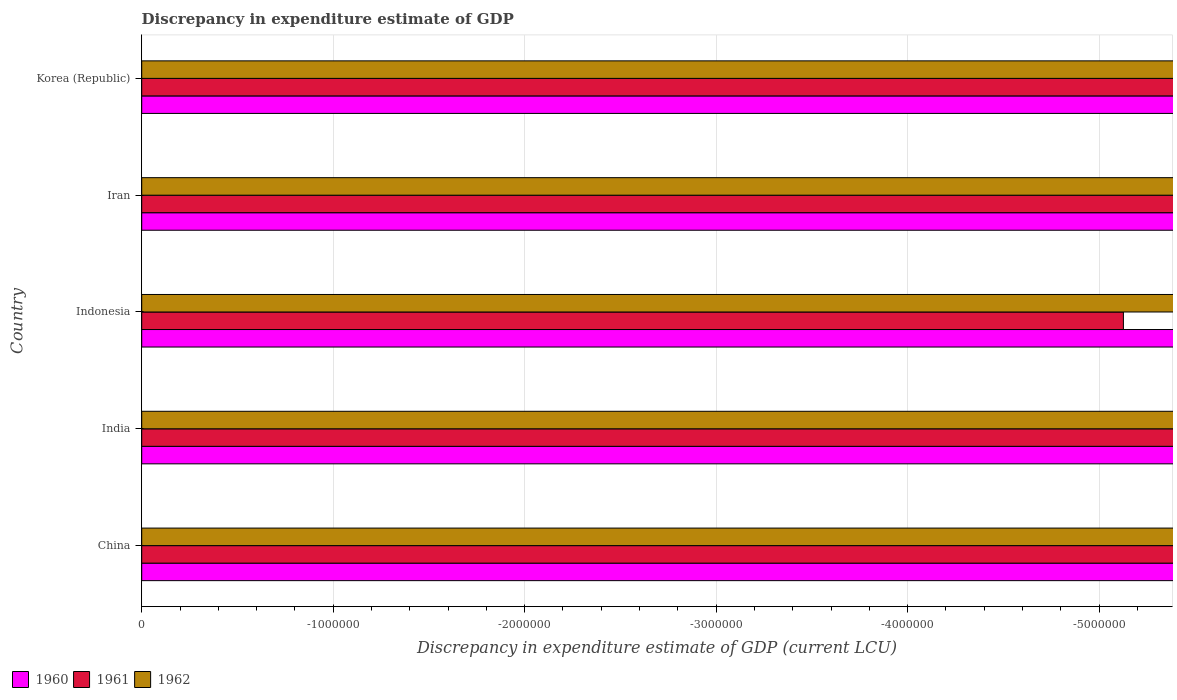How many different coloured bars are there?
Offer a terse response. 0. Are the number of bars per tick equal to the number of legend labels?
Make the answer very short. No. Are the number of bars on each tick of the Y-axis equal?
Your response must be concise. Yes. What is the label of the 1st group of bars from the top?
Provide a succinct answer. Korea (Republic). In how many cases, is the number of bars for a given country not equal to the number of legend labels?
Ensure brevity in your answer.  5. What is the discrepancy in expenditure estimate of GDP in 1960 in Iran?
Keep it short and to the point. 0. What is the average discrepancy in expenditure estimate of GDP in 1962 per country?
Offer a terse response. 0. Is it the case that in every country, the sum of the discrepancy in expenditure estimate of GDP in 1961 and discrepancy in expenditure estimate of GDP in 1960 is greater than the discrepancy in expenditure estimate of GDP in 1962?
Give a very brief answer. No. How many bars are there?
Your response must be concise. 0. What is the difference between two consecutive major ticks on the X-axis?
Your answer should be compact. 1.00e+06. Does the graph contain any zero values?
Keep it short and to the point. Yes. Does the graph contain grids?
Give a very brief answer. Yes. How are the legend labels stacked?
Provide a short and direct response. Horizontal. What is the title of the graph?
Your response must be concise. Discrepancy in expenditure estimate of GDP. Does "1969" appear as one of the legend labels in the graph?
Provide a short and direct response. No. What is the label or title of the X-axis?
Provide a short and direct response. Discrepancy in expenditure estimate of GDP (current LCU). What is the Discrepancy in expenditure estimate of GDP (current LCU) of 1960 in China?
Your response must be concise. 0. What is the Discrepancy in expenditure estimate of GDP (current LCU) of 1962 in India?
Offer a terse response. 0. What is the Discrepancy in expenditure estimate of GDP (current LCU) in 1961 in Indonesia?
Keep it short and to the point. 0. What is the Discrepancy in expenditure estimate of GDP (current LCU) in 1960 in Iran?
Provide a succinct answer. 0. What is the Discrepancy in expenditure estimate of GDP (current LCU) of 1961 in Iran?
Provide a succinct answer. 0. What is the Discrepancy in expenditure estimate of GDP (current LCU) in 1962 in Iran?
Ensure brevity in your answer.  0. What is the Discrepancy in expenditure estimate of GDP (current LCU) in 1960 in Korea (Republic)?
Your response must be concise. 0. What is the Discrepancy in expenditure estimate of GDP (current LCU) of 1962 in Korea (Republic)?
Provide a short and direct response. 0. What is the total Discrepancy in expenditure estimate of GDP (current LCU) in 1962 in the graph?
Offer a terse response. 0. 